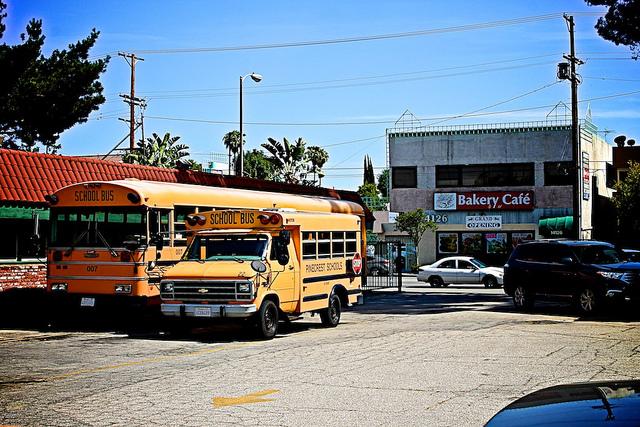Are these two buses the same?
Quick response, please. No. What is pictured in the background of this scene?
Answer briefly. Cafe. Are there clouds in the sky?
Write a very short answer. No. What is the number on the nearest bus?
Be succinct. 007. Why are there two school buses on this parking lot?
Be succinct. Waiting for school to let out. What type of cafe is in the background?
Concise answer only. Bakery. 